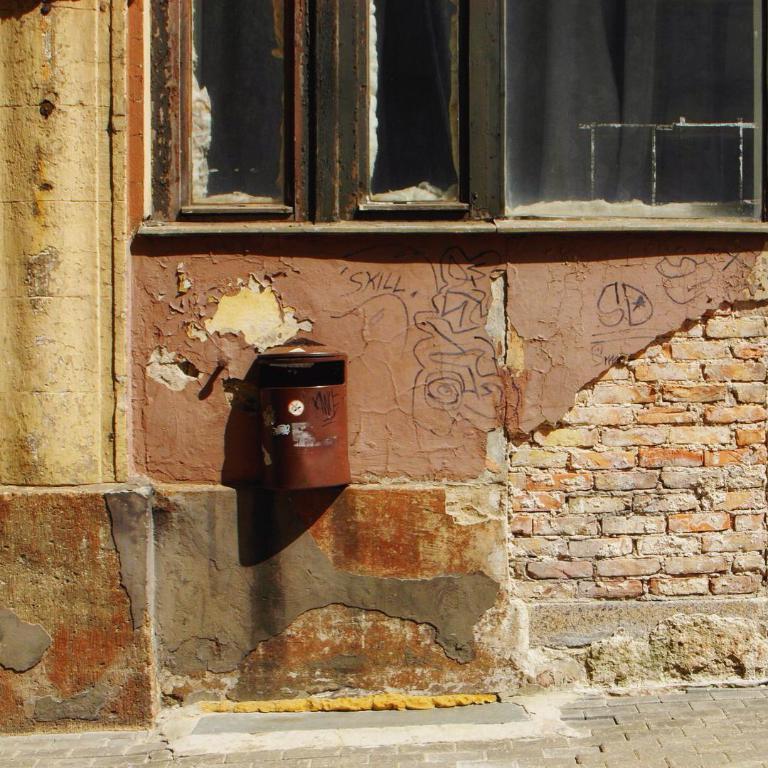Describe this image in one or two sentences. In this picture we can see mailbox on the wall and windows. 